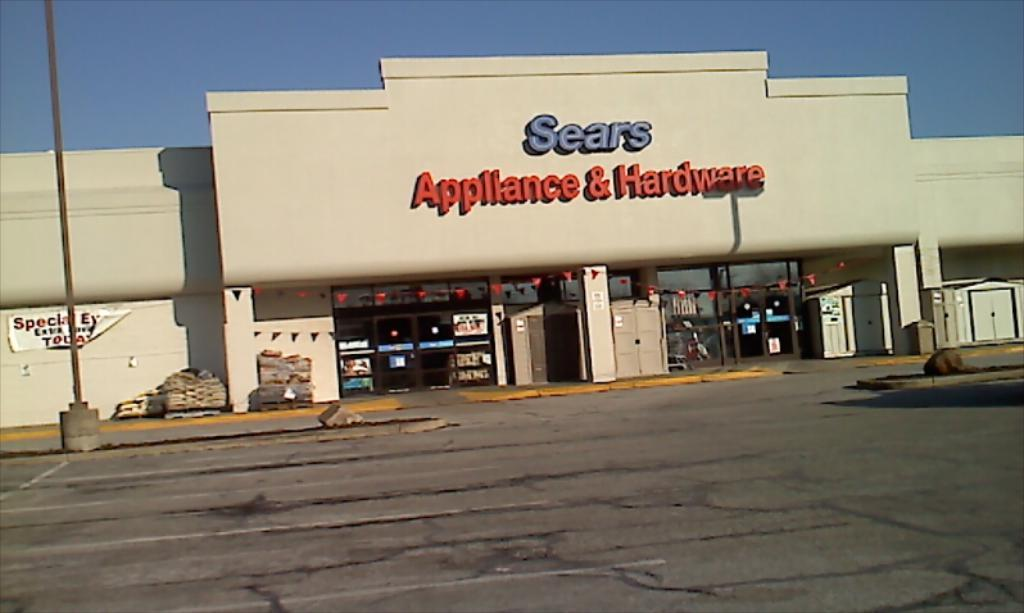What type of structure is present in the image? There is a building in the image. What can be seen on the building? There are names on the building. What other object is visible in the image? There is a pole in the image. What can be seen in the background of the image? The sky is visible in the background of the image. How many visitors are present in the image? There is no indication of visitors in the image; it only shows a building, names on the building, a pole, and the sky. What type of juice is being served in the image? There is no juice present in the image. 